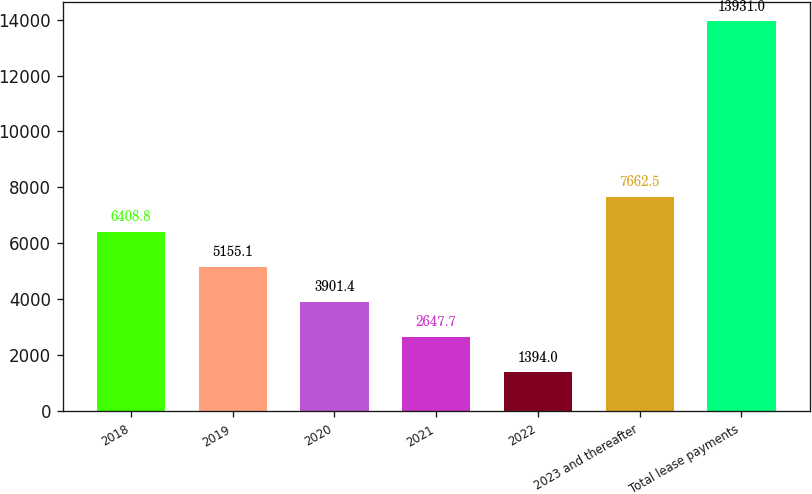Convert chart. <chart><loc_0><loc_0><loc_500><loc_500><bar_chart><fcel>2018<fcel>2019<fcel>2020<fcel>2021<fcel>2022<fcel>2023 and thereafter<fcel>Total lease payments<nl><fcel>6408.8<fcel>5155.1<fcel>3901.4<fcel>2647.7<fcel>1394<fcel>7662.5<fcel>13931<nl></chart> 